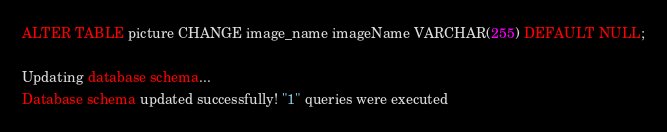<code> <loc_0><loc_0><loc_500><loc_500><_SQL_>ALTER TABLE picture CHANGE image_name imageName VARCHAR(255) DEFAULT NULL;

Updating database schema...
Database schema updated successfully! "1" queries were executed
</code> 